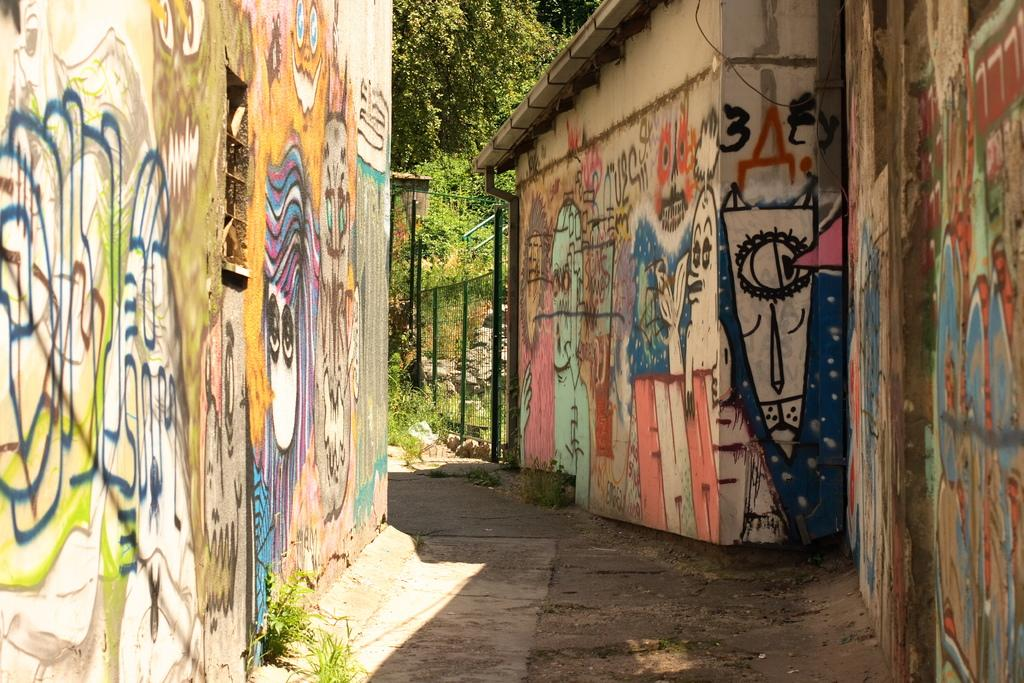What can be seen on the walls in the image? There is graffiti on the walls. What type of natural elements are visible in the distance? There are trees in the distance. What type of barrier can be seen in the image? There is a fence in the image. Can you tell me how many lizards are participating in the discussion in the image? There are no lizards or discussions present in the image. What type of wash is visible on the fence in the image? There is no wash visible on the fence in the image. 